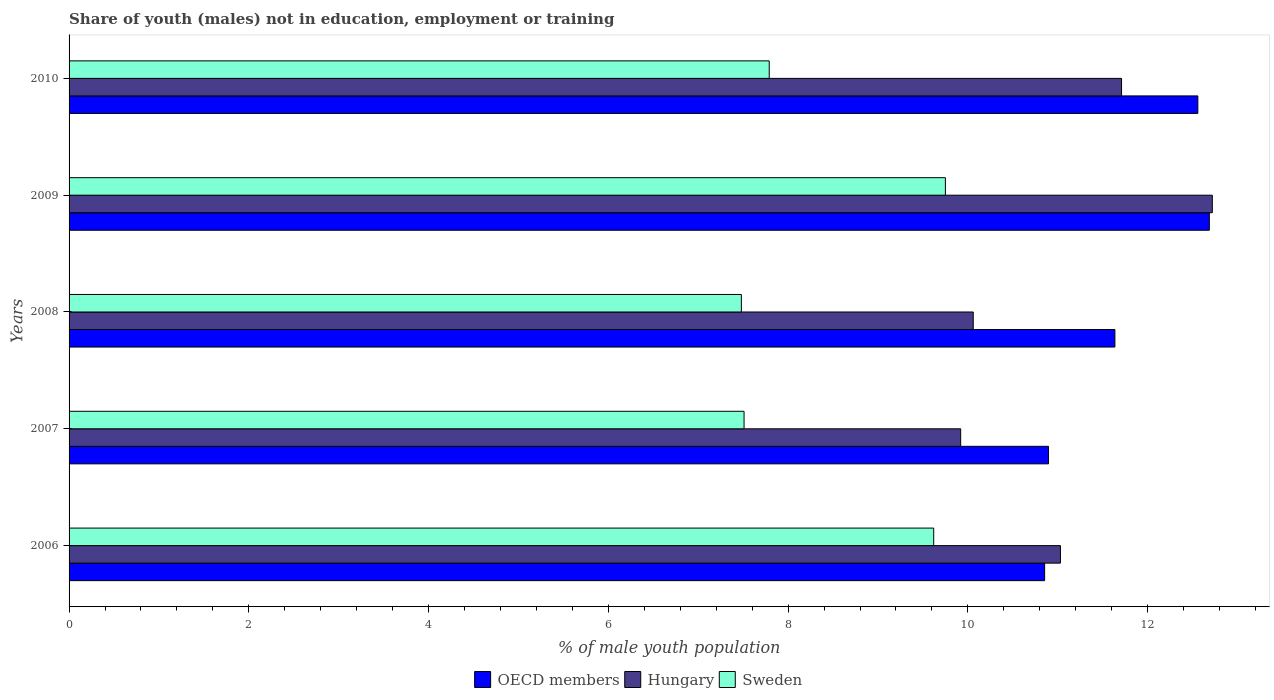How many different coloured bars are there?
Keep it short and to the point. 3. How many groups of bars are there?
Give a very brief answer. 5. How many bars are there on the 1st tick from the top?
Provide a short and direct response. 3. What is the percentage of unemployed males population in in OECD members in 2010?
Offer a terse response. 12.56. Across all years, what is the maximum percentage of unemployed males population in in Hungary?
Keep it short and to the point. 12.72. Across all years, what is the minimum percentage of unemployed males population in in Sweden?
Your answer should be compact. 7.48. In which year was the percentage of unemployed males population in in Hungary minimum?
Provide a short and direct response. 2007. What is the total percentage of unemployed males population in in OECD members in the graph?
Your answer should be compact. 58.63. What is the difference between the percentage of unemployed males population in in Sweden in 2006 and that in 2007?
Provide a short and direct response. 2.11. What is the difference between the percentage of unemployed males population in in OECD members in 2006 and the percentage of unemployed males population in in Sweden in 2010?
Your answer should be very brief. 3.06. What is the average percentage of unemployed males population in in OECD members per year?
Your answer should be compact. 11.73. In the year 2009, what is the difference between the percentage of unemployed males population in in OECD members and percentage of unemployed males population in in Hungary?
Ensure brevity in your answer.  -0.03. What is the ratio of the percentage of unemployed males population in in Sweden in 2006 to that in 2008?
Make the answer very short. 1.29. Is the percentage of unemployed males population in in Sweden in 2008 less than that in 2009?
Offer a terse response. Yes. What is the difference between the highest and the second highest percentage of unemployed males population in in Sweden?
Make the answer very short. 0.13. What is the difference between the highest and the lowest percentage of unemployed males population in in OECD members?
Provide a succinct answer. 1.83. Is the sum of the percentage of unemployed males population in in OECD members in 2009 and 2010 greater than the maximum percentage of unemployed males population in in Hungary across all years?
Your response must be concise. Yes. What does the 2nd bar from the top in 2009 represents?
Your response must be concise. Hungary. What does the 1st bar from the bottom in 2007 represents?
Give a very brief answer. OECD members. Is it the case that in every year, the sum of the percentage of unemployed males population in in Hungary and percentage of unemployed males population in in Sweden is greater than the percentage of unemployed males population in in OECD members?
Give a very brief answer. Yes. Does the graph contain any zero values?
Your response must be concise. No. Does the graph contain grids?
Your response must be concise. No. Where does the legend appear in the graph?
Offer a terse response. Bottom center. How many legend labels are there?
Make the answer very short. 3. How are the legend labels stacked?
Ensure brevity in your answer.  Horizontal. What is the title of the graph?
Keep it short and to the point. Share of youth (males) not in education, employment or training. What is the label or title of the X-axis?
Your response must be concise. % of male youth population. What is the label or title of the Y-axis?
Keep it short and to the point. Years. What is the % of male youth population in OECD members in 2006?
Provide a short and direct response. 10.85. What is the % of male youth population in Hungary in 2006?
Make the answer very short. 11.03. What is the % of male youth population of Sweden in 2006?
Give a very brief answer. 9.62. What is the % of male youth population in OECD members in 2007?
Provide a short and direct response. 10.9. What is the % of male youth population in Hungary in 2007?
Make the answer very short. 9.92. What is the % of male youth population in Sweden in 2007?
Offer a very short reply. 7.51. What is the % of male youth population of OECD members in 2008?
Your answer should be very brief. 11.64. What is the % of male youth population in Hungary in 2008?
Offer a very short reply. 10.06. What is the % of male youth population of Sweden in 2008?
Your response must be concise. 7.48. What is the % of male youth population of OECD members in 2009?
Your answer should be very brief. 12.69. What is the % of male youth population in Hungary in 2009?
Offer a very short reply. 12.72. What is the % of male youth population in Sweden in 2009?
Offer a terse response. 9.75. What is the % of male youth population in OECD members in 2010?
Offer a terse response. 12.56. What is the % of male youth population of Hungary in 2010?
Make the answer very short. 11.71. What is the % of male youth population of Sweden in 2010?
Your response must be concise. 7.79. Across all years, what is the maximum % of male youth population of OECD members?
Your answer should be compact. 12.69. Across all years, what is the maximum % of male youth population in Hungary?
Provide a short and direct response. 12.72. Across all years, what is the maximum % of male youth population of Sweden?
Offer a very short reply. 9.75. Across all years, what is the minimum % of male youth population in OECD members?
Give a very brief answer. 10.85. Across all years, what is the minimum % of male youth population of Hungary?
Your answer should be compact. 9.92. Across all years, what is the minimum % of male youth population in Sweden?
Make the answer very short. 7.48. What is the total % of male youth population of OECD members in the graph?
Offer a very short reply. 58.63. What is the total % of male youth population of Hungary in the graph?
Provide a succinct answer. 55.44. What is the total % of male youth population of Sweden in the graph?
Make the answer very short. 42.15. What is the difference between the % of male youth population of OECD members in 2006 and that in 2007?
Ensure brevity in your answer.  -0.04. What is the difference between the % of male youth population in Hungary in 2006 and that in 2007?
Your answer should be very brief. 1.11. What is the difference between the % of male youth population of Sweden in 2006 and that in 2007?
Offer a terse response. 2.11. What is the difference between the % of male youth population in OECD members in 2006 and that in 2008?
Ensure brevity in your answer.  -0.78. What is the difference between the % of male youth population in Sweden in 2006 and that in 2008?
Make the answer very short. 2.14. What is the difference between the % of male youth population in OECD members in 2006 and that in 2009?
Your answer should be very brief. -1.83. What is the difference between the % of male youth population of Hungary in 2006 and that in 2009?
Your answer should be very brief. -1.69. What is the difference between the % of male youth population of Sweden in 2006 and that in 2009?
Keep it short and to the point. -0.13. What is the difference between the % of male youth population of OECD members in 2006 and that in 2010?
Offer a terse response. -1.7. What is the difference between the % of male youth population in Hungary in 2006 and that in 2010?
Your response must be concise. -0.68. What is the difference between the % of male youth population of Sweden in 2006 and that in 2010?
Ensure brevity in your answer.  1.83. What is the difference between the % of male youth population in OECD members in 2007 and that in 2008?
Give a very brief answer. -0.74. What is the difference between the % of male youth population of Hungary in 2007 and that in 2008?
Provide a short and direct response. -0.14. What is the difference between the % of male youth population in OECD members in 2007 and that in 2009?
Your answer should be compact. -1.79. What is the difference between the % of male youth population in Hungary in 2007 and that in 2009?
Your response must be concise. -2.8. What is the difference between the % of male youth population of Sweden in 2007 and that in 2009?
Give a very brief answer. -2.24. What is the difference between the % of male youth population in OECD members in 2007 and that in 2010?
Keep it short and to the point. -1.66. What is the difference between the % of male youth population in Hungary in 2007 and that in 2010?
Offer a terse response. -1.79. What is the difference between the % of male youth population in Sweden in 2007 and that in 2010?
Give a very brief answer. -0.28. What is the difference between the % of male youth population of OECD members in 2008 and that in 2009?
Make the answer very short. -1.05. What is the difference between the % of male youth population in Hungary in 2008 and that in 2009?
Give a very brief answer. -2.66. What is the difference between the % of male youth population in Sweden in 2008 and that in 2009?
Provide a succinct answer. -2.27. What is the difference between the % of male youth population of OECD members in 2008 and that in 2010?
Ensure brevity in your answer.  -0.92. What is the difference between the % of male youth population of Hungary in 2008 and that in 2010?
Your answer should be very brief. -1.65. What is the difference between the % of male youth population of Sweden in 2008 and that in 2010?
Keep it short and to the point. -0.31. What is the difference between the % of male youth population in OECD members in 2009 and that in 2010?
Make the answer very short. 0.13. What is the difference between the % of male youth population of Hungary in 2009 and that in 2010?
Give a very brief answer. 1.01. What is the difference between the % of male youth population in Sweden in 2009 and that in 2010?
Provide a succinct answer. 1.96. What is the difference between the % of male youth population in OECD members in 2006 and the % of male youth population in Hungary in 2007?
Offer a terse response. 0.93. What is the difference between the % of male youth population in OECD members in 2006 and the % of male youth population in Sweden in 2007?
Give a very brief answer. 3.34. What is the difference between the % of male youth population in Hungary in 2006 and the % of male youth population in Sweden in 2007?
Provide a succinct answer. 3.52. What is the difference between the % of male youth population of OECD members in 2006 and the % of male youth population of Hungary in 2008?
Your response must be concise. 0.79. What is the difference between the % of male youth population of OECD members in 2006 and the % of male youth population of Sweden in 2008?
Give a very brief answer. 3.37. What is the difference between the % of male youth population in Hungary in 2006 and the % of male youth population in Sweden in 2008?
Offer a terse response. 3.55. What is the difference between the % of male youth population of OECD members in 2006 and the % of male youth population of Hungary in 2009?
Offer a terse response. -1.87. What is the difference between the % of male youth population of OECD members in 2006 and the % of male youth population of Sweden in 2009?
Ensure brevity in your answer.  1.1. What is the difference between the % of male youth population of Hungary in 2006 and the % of male youth population of Sweden in 2009?
Your response must be concise. 1.28. What is the difference between the % of male youth population of OECD members in 2006 and the % of male youth population of Hungary in 2010?
Your answer should be compact. -0.86. What is the difference between the % of male youth population of OECD members in 2006 and the % of male youth population of Sweden in 2010?
Your answer should be very brief. 3.06. What is the difference between the % of male youth population of Hungary in 2006 and the % of male youth population of Sweden in 2010?
Provide a succinct answer. 3.24. What is the difference between the % of male youth population of OECD members in 2007 and the % of male youth population of Hungary in 2008?
Offer a terse response. 0.84. What is the difference between the % of male youth population of OECD members in 2007 and the % of male youth population of Sweden in 2008?
Offer a very short reply. 3.42. What is the difference between the % of male youth population of Hungary in 2007 and the % of male youth population of Sweden in 2008?
Offer a very short reply. 2.44. What is the difference between the % of male youth population of OECD members in 2007 and the % of male youth population of Hungary in 2009?
Keep it short and to the point. -1.82. What is the difference between the % of male youth population of OECD members in 2007 and the % of male youth population of Sweden in 2009?
Provide a short and direct response. 1.15. What is the difference between the % of male youth population of Hungary in 2007 and the % of male youth population of Sweden in 2009?
Provide a succinct answer. 0.17. What is the difference between the % of male youth population of OECD members in 2007 and the % of male youth population of Hungary in 2010?
Keep it short and to the point. -0.81. What is the difference between the % of male youth population of OECD members in 2007 and the % of male youth population of Sweden in 2010?
Ensure brevity in your answer.  3.11. What is the difference between the % of male youth population in Hungary in 2007 and the % of male youth population in Sweden in 2010?
Provide a short and direct response. 2.13. What is the difference between the % of male youth population in OECD members in 2008 and the % of male youth population in Hungary in 2009?
Keep it short and to the point. -1.08. What is the difference between the % of male youth population in OECD members in 2008 and the % of male youth population in Sweden in 2009?
Your response must be concise. 1.89. What is the difference between the % of male youth population in Hungary in 2008 and the % of male youth population in Sweden in 2009?
Ensure brevity in your answer.  0.31. What is the difference between the % of male youth population in OECD members in 2008 and the % of male youth population in Hungary in 2010?
Provide a short and direct response. -0.07. What is the difference between the % of male youth population of OECD members in 2008 and the % of male youth population of Sweden in 2010?
Give a very brief answer. 3.85. What is the difference between the % of male youth population of Hungary in 2008 and the % of male youth population of Sweden in 2010?
Make the answer very short. 2.27. What is the difference between the % of male youth population in OECD members in 2009 and the % of male youth population in Hungary in 2010?
Provide a succinct answer. 0.98. What is the difference between the % of male youth population in OECD members in 2009 and the % of male youth population in Sweden in 2010?
Give a very brief answer. 4.9. What is the difference between the % of male youth population of Hungary in 2009 and the % of male youth population of Sweden in 2010?
Provide a succinct answer. 4.93. What is the average % of male youth population of OECD members per year?
Offer a very short reply. 11.73. What is the average % of male youth population of Hungary per year?
Give a very brief answer. 11.09. What is the average % of male youth population of Sweden per year?
Provide a short and direct response. 8.43. In the year 2006, what is the difference between the % of male youth population of OECD members and % of male youth population of Hungary?
Make the answer very short. -0.18. In the year 2006, what is the difference between the % of male youth population of OECD members and % of male youth population of Sweden?
Provide a succinct answer. 1.23. In the year 2006, what is the difference between the % of male youth population in Hungary and % of male youth population in Sweden?
Provide a succinct answer. 1.41. In the year 2007, what is the difference between the % of male youth population of OECD members and % of male youth population of Hungary?
Your answer should be very brief. 0.98. In the year 2007, what is the difference between the % of male youth population in OECD members and % of male youth population in Sweden?
Provide a succinct answer. 3.39. In the year 2007, what is the difference between the % of male youth population in Hungary and % of male youth population in Sweden?
Provide a short and direct response. 2.41. In the year 2008, what is the difference between the % of male youth population in OECD members and % of male youth population in Hungary?
Make the answer very short. 1.58. In the year 2008, what is the difference between the % of male youth population of OECD members and % of male youth population of Sweden?
Your answer should be very brief. 4.16. In the year 2008, what is the difference between the % of male youth population of Hungary and % of male youth population of Sweden?
Your answer should be very brief. 2.58. In the year 2009, what is the difference between the % of male youth population in OECD members and % of male youth population in Hungary?
Your answer should be very brief. -0.03. In the year 2009, what is the difference between the % of male youth population in OECD members and % of male youth population in Sweden?
Ensure brevity in your answer.  2.94. In the year 2009, what is the difference between the % of male youth population of Hungary and % of male youth population of Sweden?
Give a very brief answer. 2.97. In the year 2010, what is the difference between the % of male youth population in OECD members and % of male youth population in Hungary?
Your response must be concise. 0.85. In the year 2010, what is the difference between the % of male youth population of OECD members and % of male youth population of Sweden?
Your answer should be very brief. 4.77. In the year 2010, what is the difference between the % of male youth population in Hungary and % of male youth population in Sweden?
Make the answer very short. 3.92. What is the ratio of the % of male youth population in OECD members in 2006 to that in 2007?
Ensure brevity in your answer.  1. What is the ratio of the % of male youth population in Hungary in 2006 to that in 2007?
Your answer should be compact. 1.11. What is the ratio of the % of male youth population of Sweden in 2006 to that in 2007?
Ensure brevity in your answer.  1.28. What is the ratio of the % of male youth population in OECD members in 2006 to that in 2008?
Give a very brief answer. 0.93. What is the ratio of the % of male youth population of Hungary in 2006 to that in 2008?
Your answer should be very brief. 1.1. What is the ratio of the % of male youth population in Sweden in 2006 to that in 2008?
Make the answer very short. 1.29. What is the ratio of the % of male youth population in OECD members in 2006 to that in 2009?
Provide a short and direct response. 0.86. What is the ratio of the % of male youth population of Hungary in 2006 to that in 2009?
Keep it short and to the point. 0.87. What is the ratio of the % of male youth population in Sweden in 2006 to that in 2009?
Ensure brevity in your answer.  0.99. What is the ratio of the % of male youth population of OECD members in 2006 to that in 2010?
Give a very brief answer. 0.86. What is the ratio of the % of male youth population in Hungary in 2006 to that in 2010?
Ensure brevity in your answer.  0.94. What is the ratio of the % of male youth population of Sweden in 2006 to that in 2010?
Provide a short and direct response. 1.23. What is the ratio of the % of male youth population in OECD members in 2007 to that in 2008?
Keep it short and to the point. 0.94. What is the ratio of the % of male youth population of Hungary in 2007 to that in 2008?
Provide a succinct answer. 0.99. What is the ratio of the % of male youth population of Sweden in 2007 to that in 2008?
Keep it short and to the point. 1. What is the ratio of the % of male youth population of OECD members in 2007 to that in 2009?
Your answer should be very brief. 0.86. What is the ratio of the % of male youth population of Hungary in 2007 to that in 2009?
Give a very brief answer. 0.78. What is the ratio of the % of male youth population of Sweden in 2007 to that in 2009?
Provide a succinct answer. 0.77. What is the ratio of the % of male youth population of OECD members in 2007 to that in 2010?
Your answer should be compact. 0.87. What is the ratio of the % of male youth population in Hungary in 2007 to that in 2010?
Your answer should be compact. 0.85. What is the ratio of the % of male youth population in Sweden in 2007 to that in 2010?
Give a very brief answer. 0.96. What is the ratio of the % of male youth population of OECD members in 2008 to that in 2009?
Make the answer very short. 0.92. What is the ratio of the % of male youth population of Hungary in 2008 to that in 2009?
Your response must be concise. 0.79. What is the ratio of the % of male youth population in Sweden in 2008 to that in 2009?
Provide a short and direct response. 0.77. What is the ratio of the % of male youth population of OECD members in 2008 to that in 2010?
Make the answer very short. 0.93. What is the ratio of the % of male youth population in Hungary in 2008 to that in 2010?
Give a very brief answer. 0.86. What is the ratio of the % of male youth population in Sweden in 2008 to that in 2010?
Provide a short and direct response. 0.96. What is the ratio of the % of male youth population in OECD members in 2009 to that in 2010?
Give a very brief answer. 1.01. What is the ratio of the % of male youth population in Hungary in 2009 to that in 2010?
Offer a terse response. 1.09. What is the ratio of the % of male youth population of Sweden in 2009 to that in 2010?
Your response must be concise. 1.25. What is the difference between the highest and the second highest % of male youth population of OECD members?
Offer a very short reply. 0.13. What is the difference between the highest and the second highest % of male youth population of Hungary?
Provide a short and direct response. 1.01. What is the difference between the highest and the second highest % of male youth population in Sweden?
Your answer should be compact. 0.13. What is the difference between the highest and the lowest % of male youth population of OECD members?
Keep it short and to the point. 1.83. What is the difference between the highest and the lowest % of male youth population in Hungary?
Make the answer very short. 2.8. What is the difference between the highest and the lowest % of male youth population in Sweden?
Your response must be concise. 2.27. 